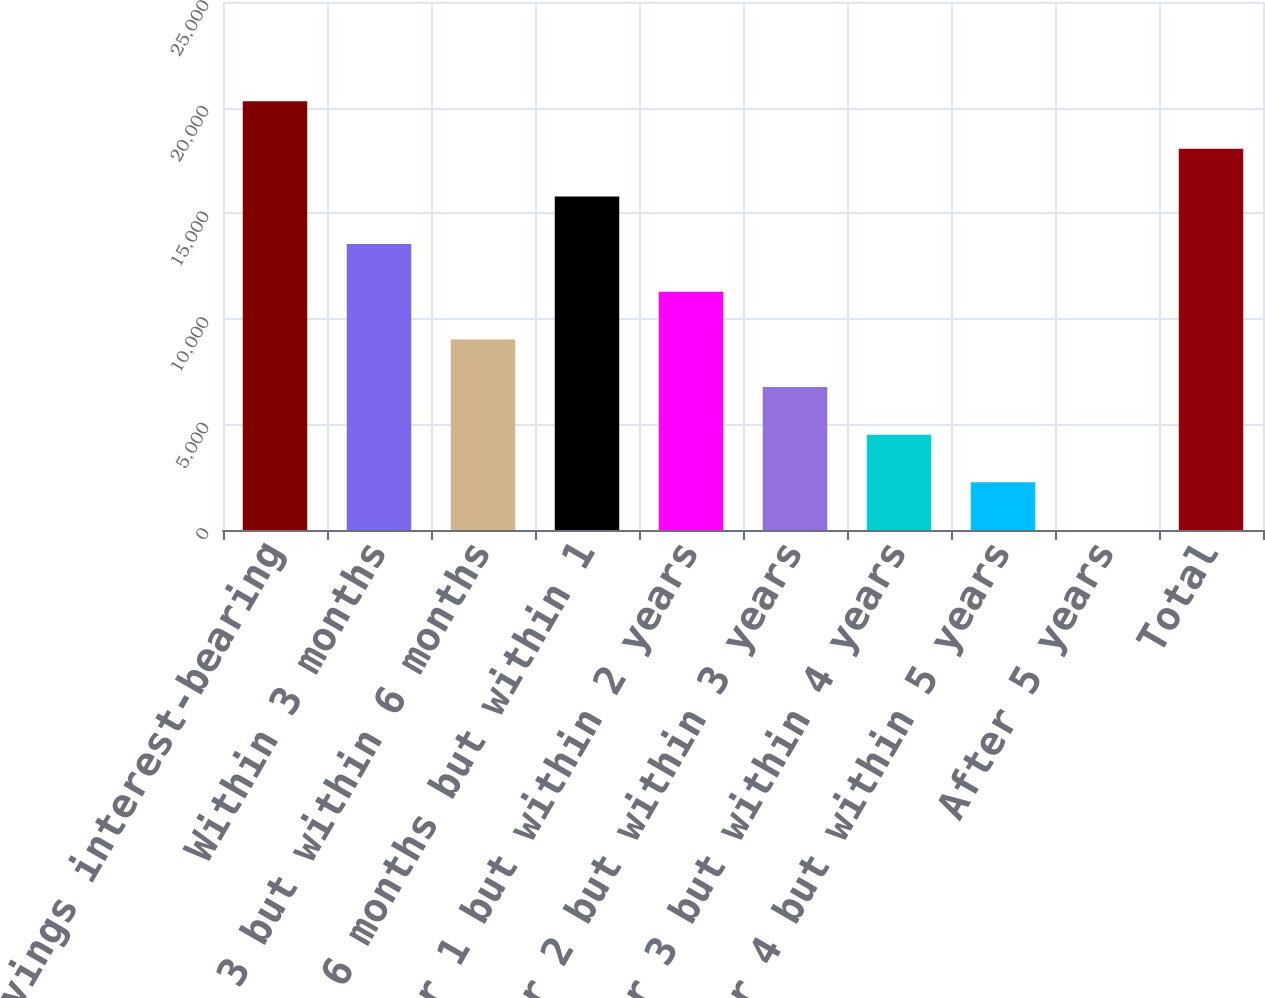Convert chart. <chart><loc_0><loc_0><loc_500><loc_500><bar_chart><fcel>Savings interest-bearing<fcel>Within 3 months<fcel>After 3 but within 6 months<fcel>After 6 months but within 1<fcel>After 1 but within 2 years<fcel>After 2 but within 3 years<fcel>After 3 but within 4 years<fcel>After 4 but within 5 years<fcel>After 5 years<fcel>Total<nl><fcel>20302<fcel>13536.1<fcel>9025.44<fcel>15791.4<fcel>11280.8<fcel>6770.13<fcel>4514.82<fcel>2259.51<fcel>4.2<fcel>18046.7<nl></chart> 